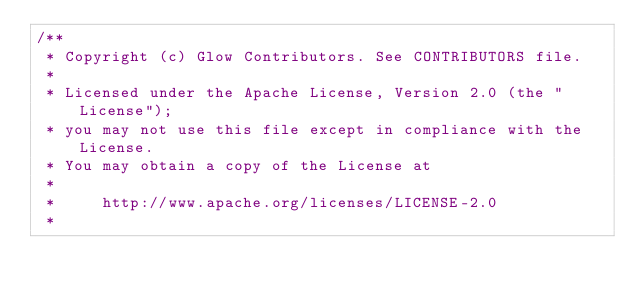Convert code to text. <code><loc_0><loc_0><loc_500><loc_500><_C++_>/**
 * Copyright (c) Glow Contributors. See CONTRIBUTORS file.
 *
 * Licensed under the Apache License, Version 2.0 (the "License");
 * you may not use this file except in compliance with the License.
 * You may obtain a copy of the License at
 *
 *     http://www.apache.org/licenses/LICENSE-2.0
 *</code> 